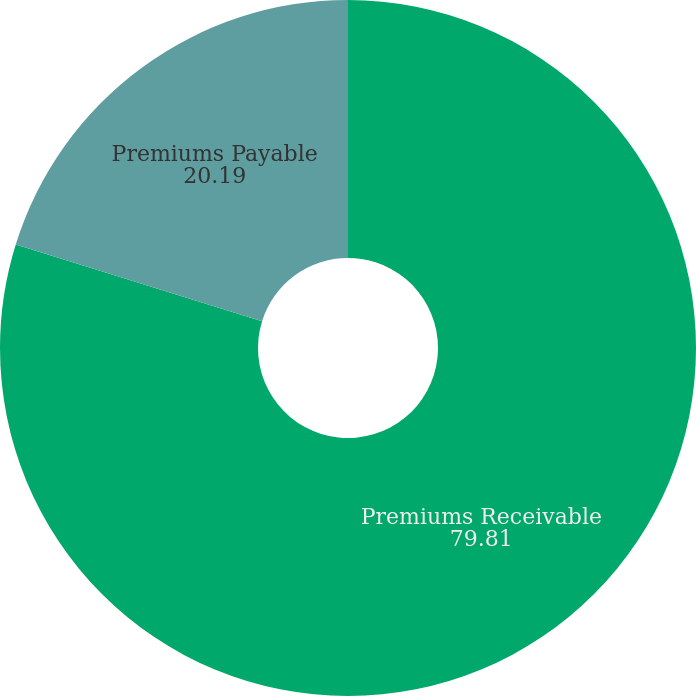Convert chart to OTSL. <chart><loc_0><loc_0><loc_500><loc_500><pie_chart><fcel>Premiums Receivable<fcel>Premiums Payable<nl><fcel>79.81%<fcel>20.19%<nl></chart> 